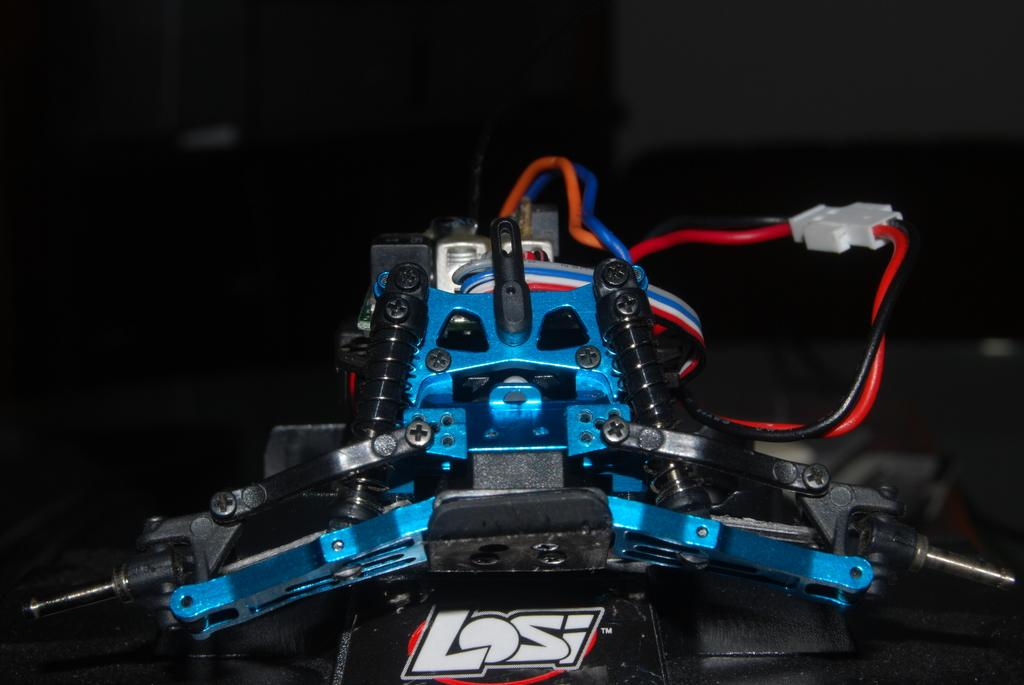What type of electronic device is visible in the image? There is an electronic device in the image, but the specific type is not mentioned in the facts. Are there any connections to the electronic device? Yes, there are wires connected to the electronic device. What else can be seen in the image besides the electronic device and wires? There are other objects present in the image, but their specific details are not mentioned in the facts. What type of band is performing in the image? There is no band present in the image; it only features an electronic device with wires and other unspecified objects. 